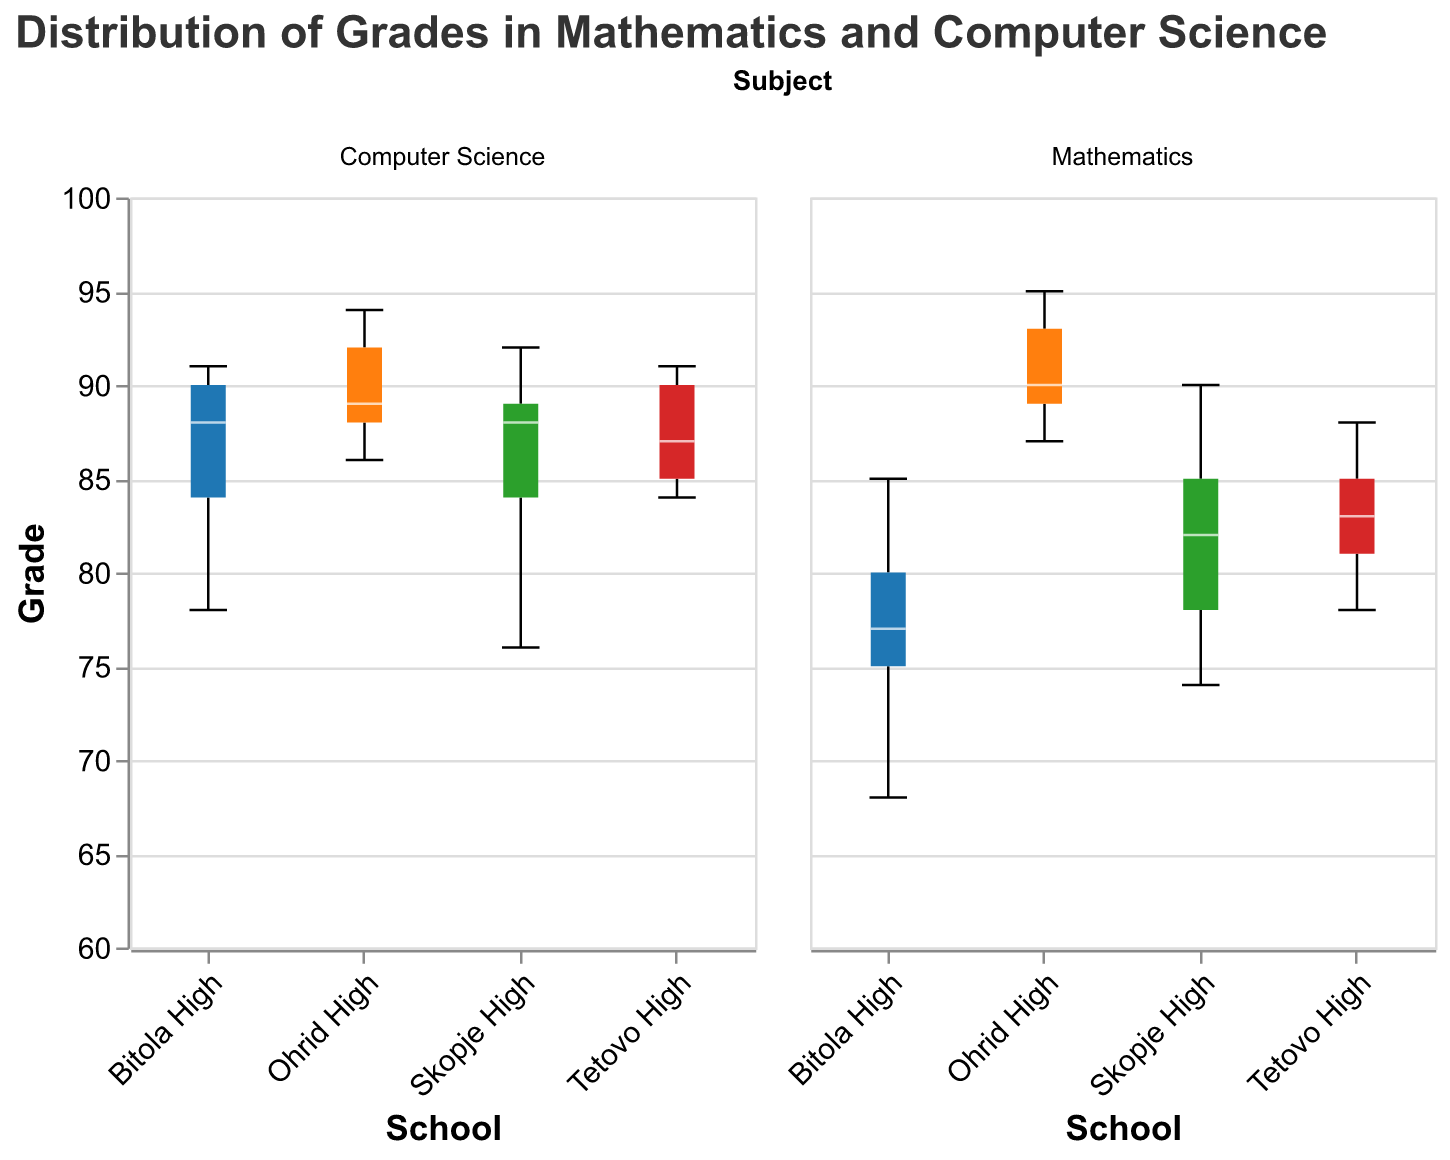What is the median grade for Mathematics at Skopje High? To find the median grade for Mathematics at Skopje High, locate the middle value in the list when the grades are ordered. The grades are 74, 78, 82, 85, 90. The median is the middle value, which is 82.
Answer: 82 Which school has the highest median grade for Computer Science? Compare the median grades for Computer Science across all schools. Skopje High has a median of 88, Bitola High has a median of 88, Ohrid High has a median of 89, and Tetovo High has a median of 87. Therefore, Ohrid High has the highest median.
Answer: Ohrid High What is the range of grades for Mathematics at Bitola High? To find the range, subtract the lowest grade from the highest grade for Mathematics at Bitola High. The grades are 68, 75, 77, 80, 85. So, 85 - 68 = 17.
Answer: 17 Which subject has a higher variability in grades at Tetovo High? Variability can be assessed by the interquartile range or the overall range in the box plot. For Mathematics at Tetovo High, the grades range from 78 to 88, and for Computer Science, the range is from 84 to 91. Both ranges are relatively close, but Computer Science shows a slight larger interquartile range as well.
Answer: Computer Science How does the median grade of Mathematics at Ohrid High compare to that of Bitola High? The median grade for Mathematics at Ohrid High is higher than that at Bitola High. Ohrid High's median grade is within 87-89, while Bitola High’s median is 75.
Answer: Ohrid High's median is higher What is the interquartile range (IQR) for Computer Science grades at Skopje High? Interquartile range is calculated by subtracting the first quartile (Q1) value from the third quartile (Q3) value. For Skopje High, the Q1 is around 84, and the Q3 is around 89 for Computer Science. So, the IQR is 89 - 84 = 5.
Answer: 5 Which school shows the widest overall spread in Mathematics grades? The overall spread can be measured by the range; compare the box plot whiskers. Ohrid High has the widest spread as the grades range from 87 to 95.
Answer: Ohrid High Are there any outliers in the Mathematics grades for any school? In box plots, outliers are typically highlighted as points beyond the whiskers. No outliers are visible in the Mathematics grades for any of the schools indicating all grades fall within the normal range.
Answer: No Which subject has higher median grades overall across all schools? By comparing the median lines of the box plots across all schools, you can see that the median grades for Computer Science are overall higher when compared to Mathematics.
Answer: Computer Science 